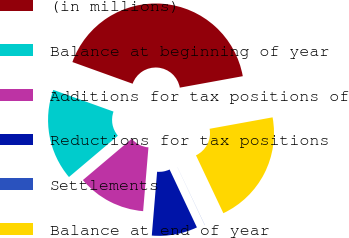<chart> <loc_0><loc_0><loc_500><loc_500><pie_chart><fcel>(in millions)<fcel>Balance at beginning of year<fcel>Additions for tax positions of<fcel>Reductions for tax positions<fcel>Settlements<fcel>Balance at end of year<nl><fcel>41.64%<fcel>16.67%<fcel>12.51%<fcel>8.34%<fcel>0.02%<fcel>20.83%<nl></chart> 